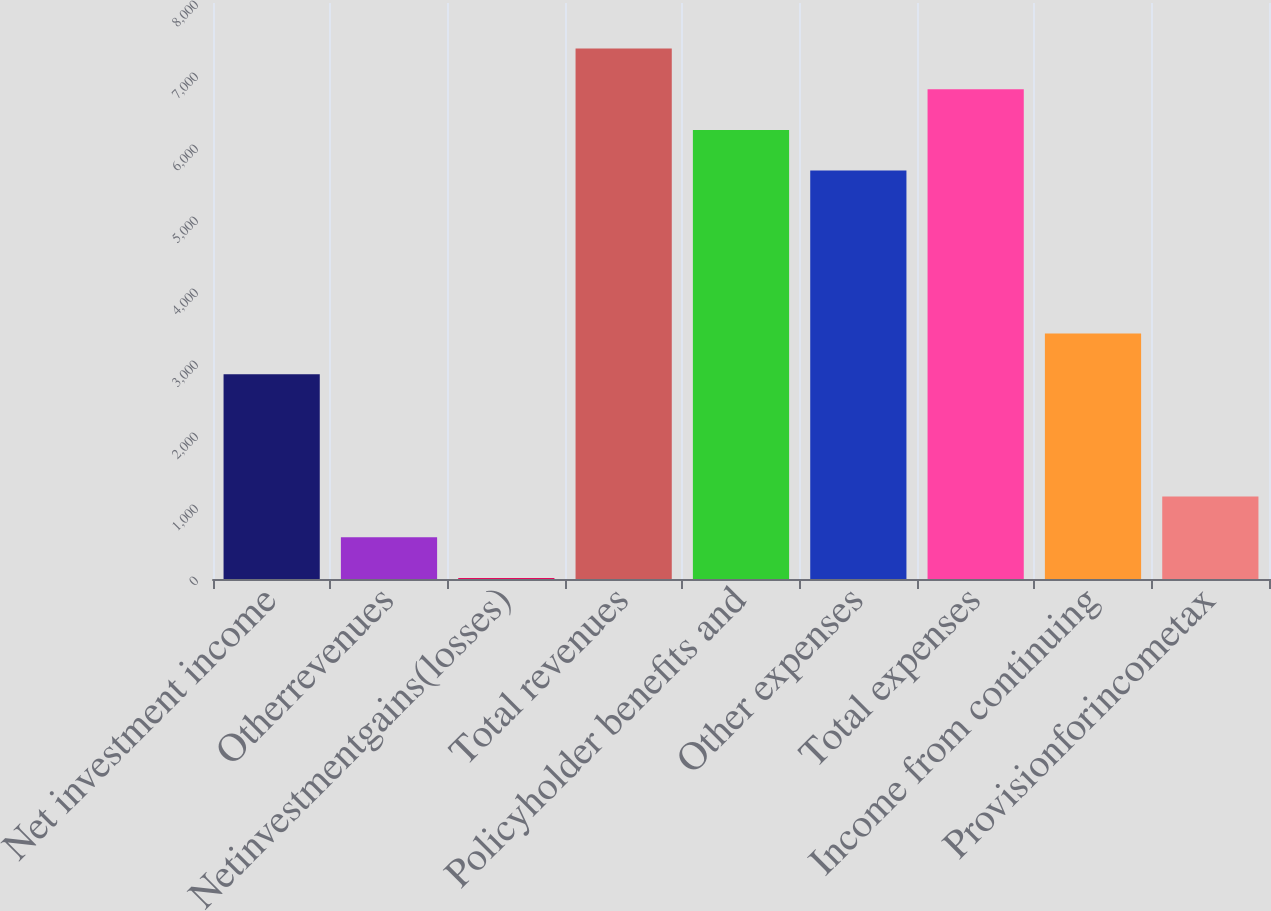<chart> <loc_0><loc_0><loc_500><loc_500><bar_chart><fcel>Net investment income<fcel>Otherrevenues<fcel>Netinvestmentgains(losses)<fcel>Total revenues<fcel>Policyholder benefits and<fcel>Other expenses<fcel>Total expenses<fcel>Income from continuing<fcel>Provisionforincometax<nl><fcel>2843.5<fcel>580.7<fcel>15<fcel>7369.1<fcel>6237.7<fcel>5672<fcel>6803.4<fcel>3409.2<fcel>1146.4<nl></chart> 